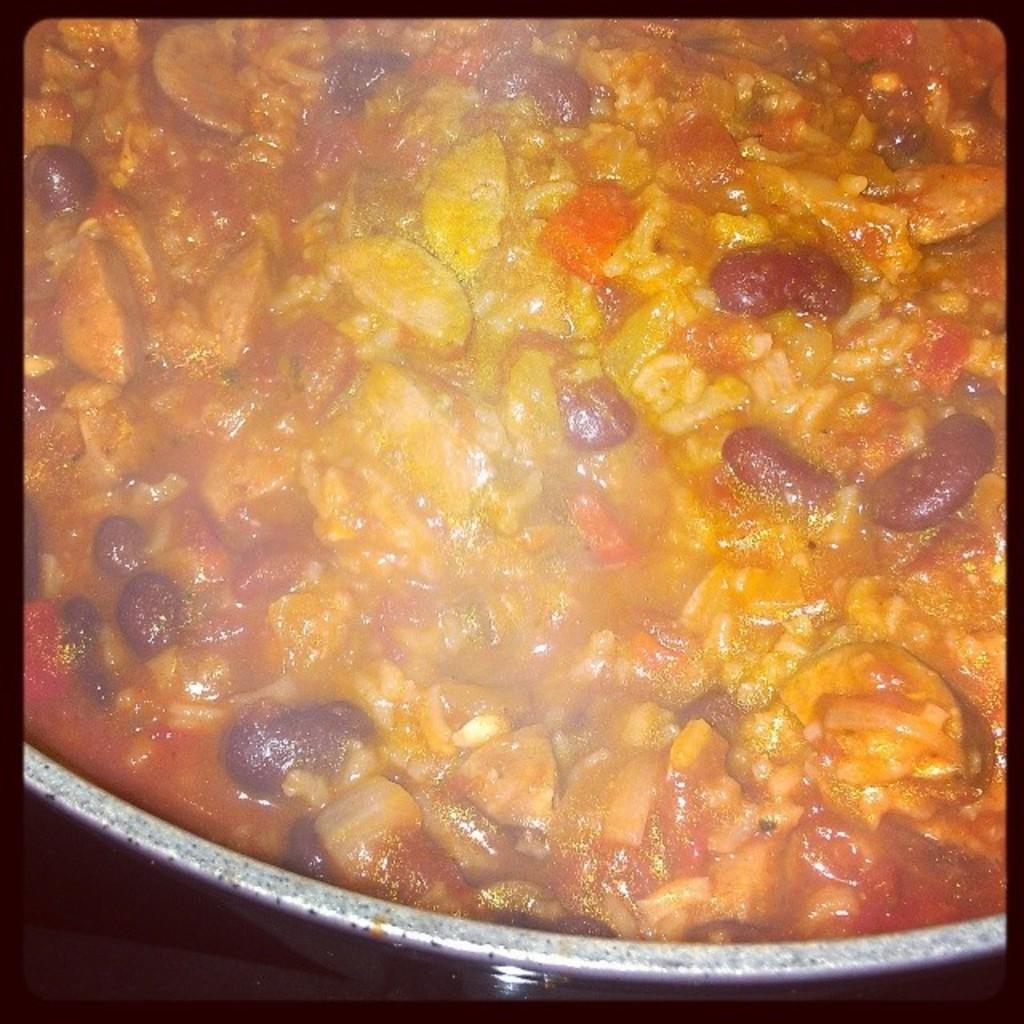What can be observed around the edges of the image? The image has black borders. How does the image appear in terms of focus? The image appears to be zoomed. What is the main subject of the image? There is a platter containing some food item in the center of the image. How does the leaf in the image contribute to the washing process? There is no leaf present in the image, so it cannot contribute to any washing process. 